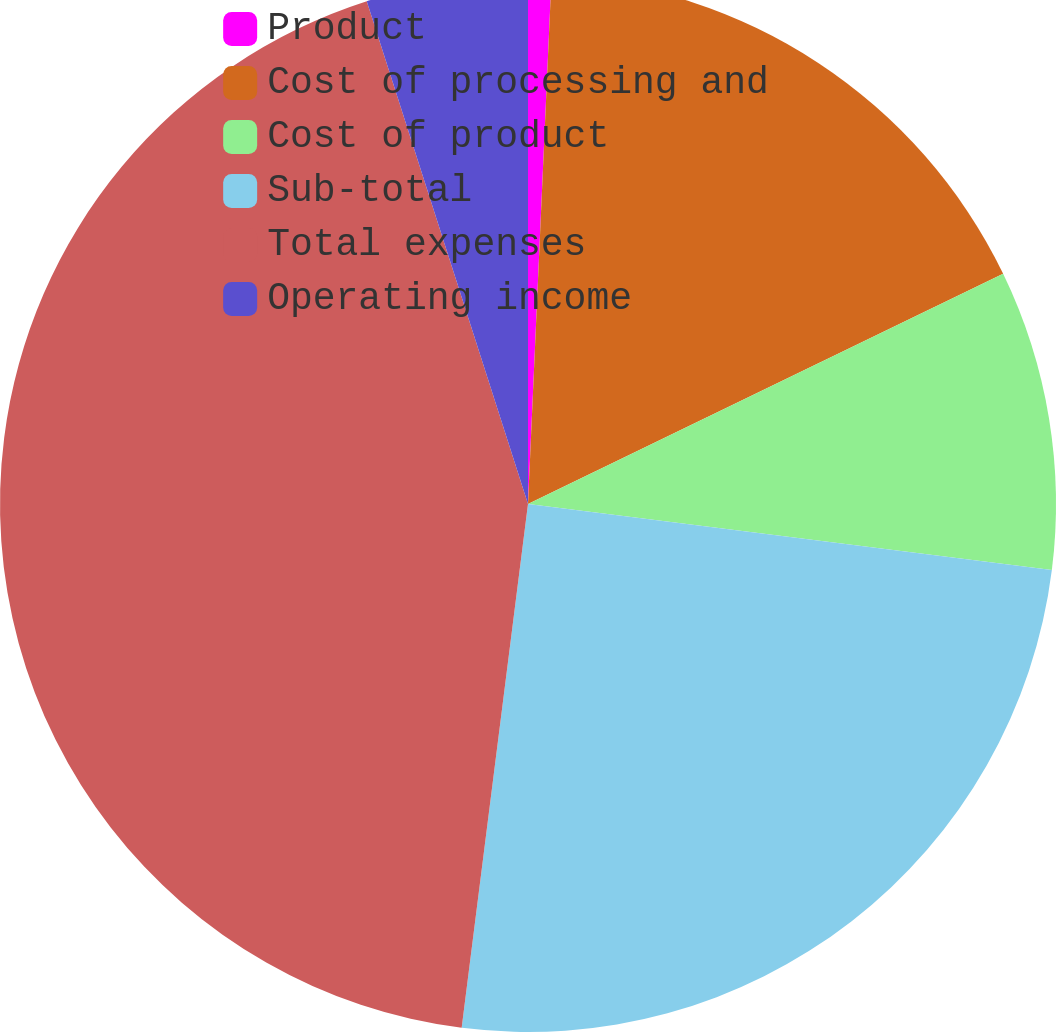Convert chart. <chart><loc_0><loc_0><loc_500><loc_500><pie_chart><fcel>Product<fcel>Cost of processing and<fcel>Cost of product<fcel>Sub-total<fcel>Total expenses<fcel>Operating income<nl><fcel>0.71%<fcel>17.11%<fcel>9.18%<fcel>25.01%<fcel>43.06%<fcel>4.94%<nl></chart> 